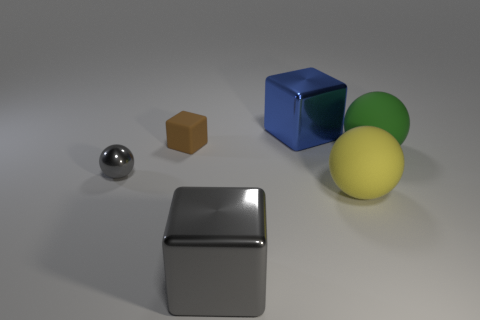Are there any yellow rubber things left of the gray sphere?
Offer a terse response. No. Is the number of big gray cubes that are on the left side of the tiny matte object the same as the number of large things?
Offer a very short reply. No. There is a yellow object that is the same size as the gray block; what shape is it?
Offer a very short reply. Sphere. What material is the green thing?
Offer a terse response. Rubber. What is the color of the metallic thing that is both right of the small brown matte cube and in front of the small brown matte block?
Provide a short and direct response. Gray. Is the number of tiny brown rubber objects that are on the left side of the brown thing the same as the number of green matte objects that are on the right side of the green matte sphere?
Your answer should be compact. Yes. What is the color of the tiny thing that is the same material as the yellow sphere?
Your answer should be very brief. Brown. There is a tiny ball; does it have the same color as the large shiny block to the left of the blue metal object?
Your response must be concise. Yes. There is a big rubber object right of the yellow thing that is in front of the brown object; is there a shiny cube right of it?
Provide a short and direct response. No. The small thing that is made of the same material as the big blue block is what shape?
Your answer should be compact. Sphere. 